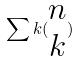<formula> <loc_0><loc_0><loc_500><loc_500>\sum k ( \begin{matrix} n \\ k \end{matrix} )</formula> 